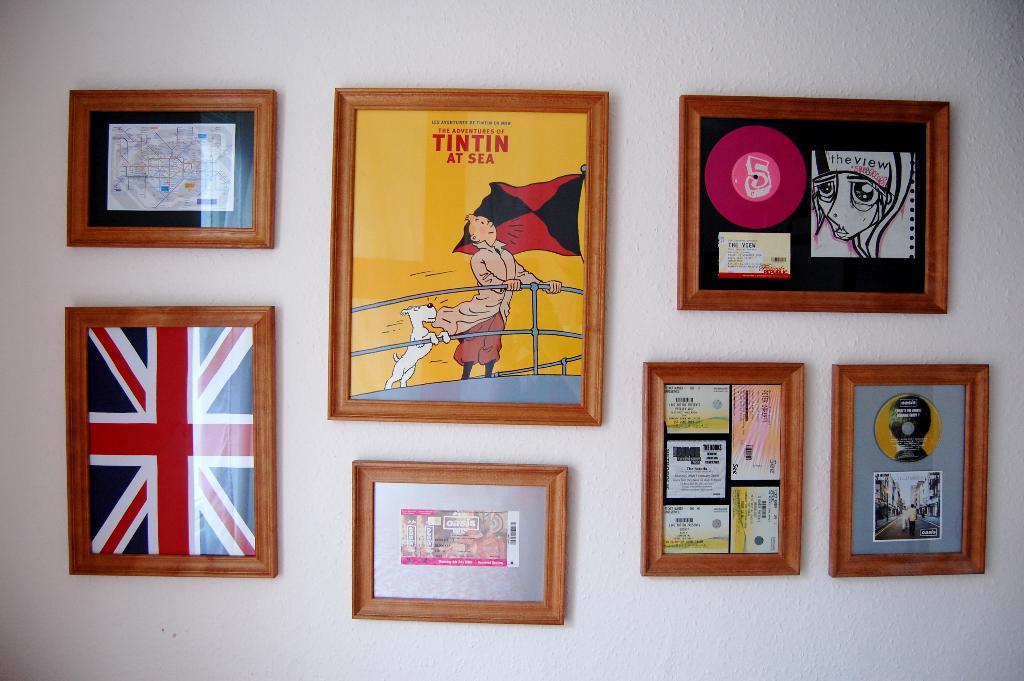Could you give a brief overview of what you see in this image? We can see frames on a white wall. 